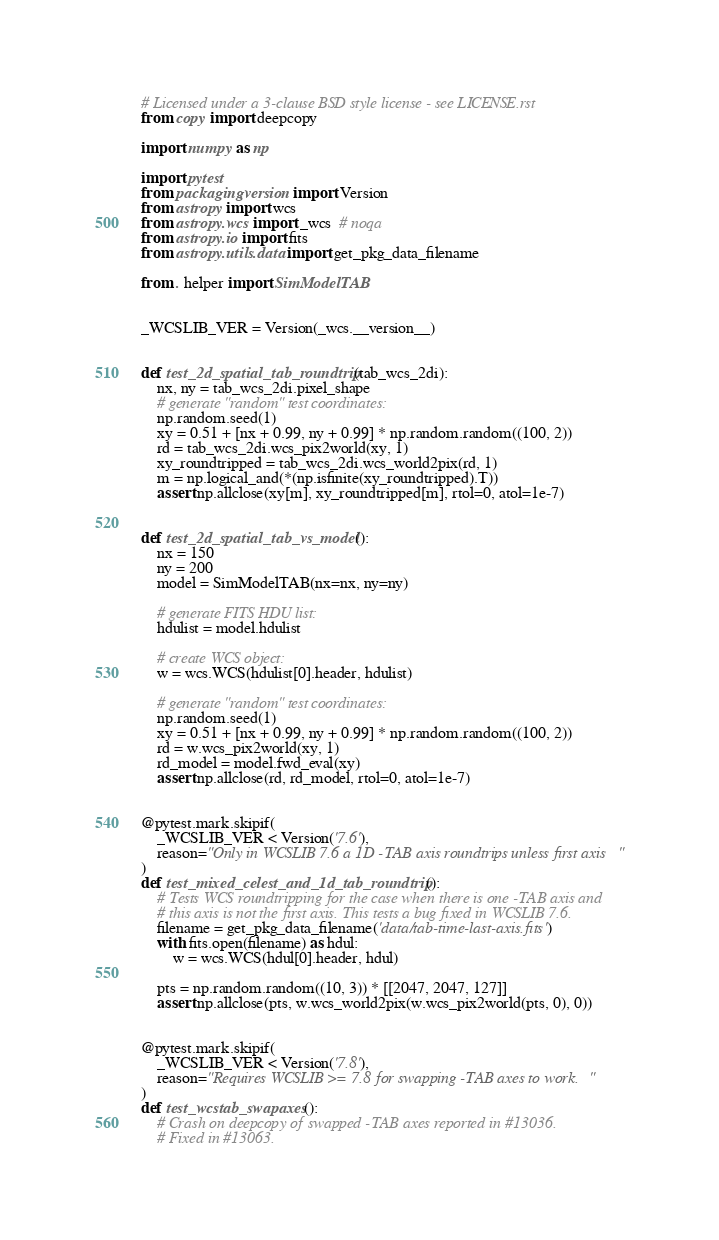Convert code to text. <code><loc_0><loc_0><loc_500><loc_500><_Python_># Licensed under a 3-clause BSD style license - see LICENSE.rst
from copy import deepcopy

import numpy as np

import pytest
from packaging.version import Version
from astropy import wcs
from astropy.wcs import _wcs  # noqa
from astropy.io import fits
from astropy.utils.data import get_pkg_data_filename

from . helper import SimModelTAB


_WCSLIB_VER = Version(_wcs.__version__)


def test_2d_spatial_tab_roundtrip(tab_wcs_2di):
    nx, ny = tab_wcs_2di.pixel_shape
    # generate "random" test coordinates:
    np.random.seed(1)
    xy = 0.51 + [nx + 0.99, ny + 0.99] * np.random.random((100, 2))
    rd = tab_wcs_2di.wcs_pix2world(xy, 1)
    xy_roundtripped = tab_wcs_2di.wcs_world2pix(rd, 1)
    m = np.logical_and(*(np.isfinite(xy_roundtripped).T))
    assert np.allclose(xy[m], xy_roundtripped[m], rtol=0, atol=1e-7)


def test_2d_spatial_tab_vs_model():
    nx = 150
    ny = 200
    model = SimModelTAB(nx=nx, ny=ny)

    # generate FITS HDU list:
    hdulist = model.hdulist

    # create WCS object:
    w = wcs.WCS(hdulist[0].header, hdulist)

    # generate "random" test coordinates:
    np.random.seed(1)
    xy = 0.51 + [nx + 0.99, ny + 0.99] * np.random.random((100, 2))
    rd = w.wcs_pix2world(xy, 1)
    rd_model = model.fwd_eval(xy)
    assert np.allclose(rd, rd_model, rtol=0, atol=1e-7)


@pytest.mark.skipif(
    _WCSLIB_VER < Version('7.6'),
    reason="Only in WCSLIB 7.6 a 1D -TAB axis roundtrips unless first axis"
)
def test_mixed_celest_and_1d_tab_roundtrip():
    # Tests WCS roundtripping for the case when there is one -TAB axis and
    # this axis is not the first axis. This tests a bug fixed in WCSLIB 7.6.
    filename = get_pkg_data_filename('data/tab-time-last-axis.fits')
    with fits.open(filename) as hdul:
        w = wcs.WCS(hdul[0].header, hdul)

    pts = np.random.random((10, 3)) * [[2047, 2047, 127]]
    assert np.allclose(pts, w.wcs_world2pix(w.wcs_pix2world(pts, 0), 0))


@pytest.mark.skipif(
    _WCSLIB_VER < Version('7.8'),
    reason="Requires WCSLIB >= 7.8 for swapping -TAB axes to work."
)
def test_wcstab_swapaxes():
    # Crash on deepcopy of swapped -TAB axes reported in #13036.
    # Fixed in #13063.</code> 